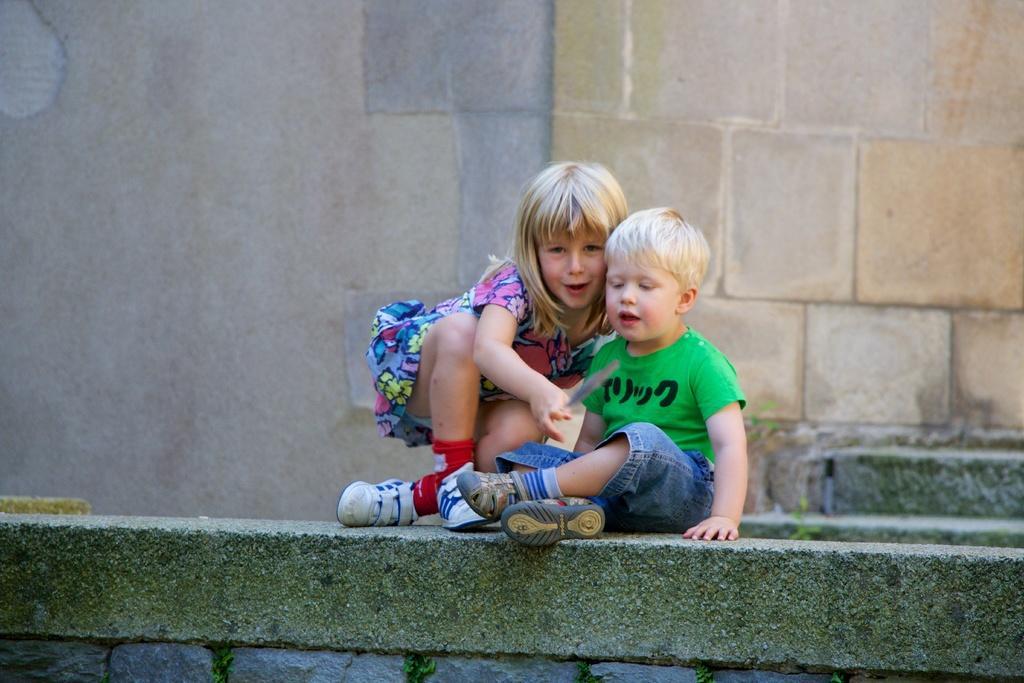Describe this image in one or two sentences. In this picture we can see a girl and a boy wore shoes and sitting on a platform and in the background we can see wall. 